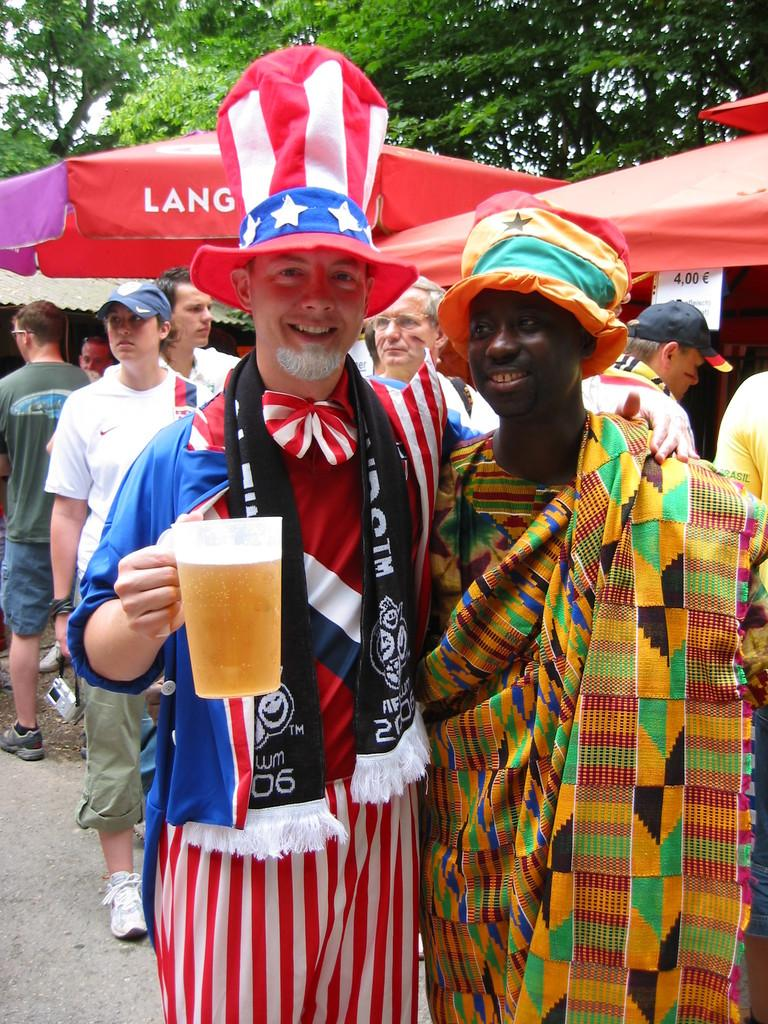<image>
Relay a brief, clear account of the picture shown. A man is holding a huge beer in front of an umbrella with a word that starts with lang on it. 